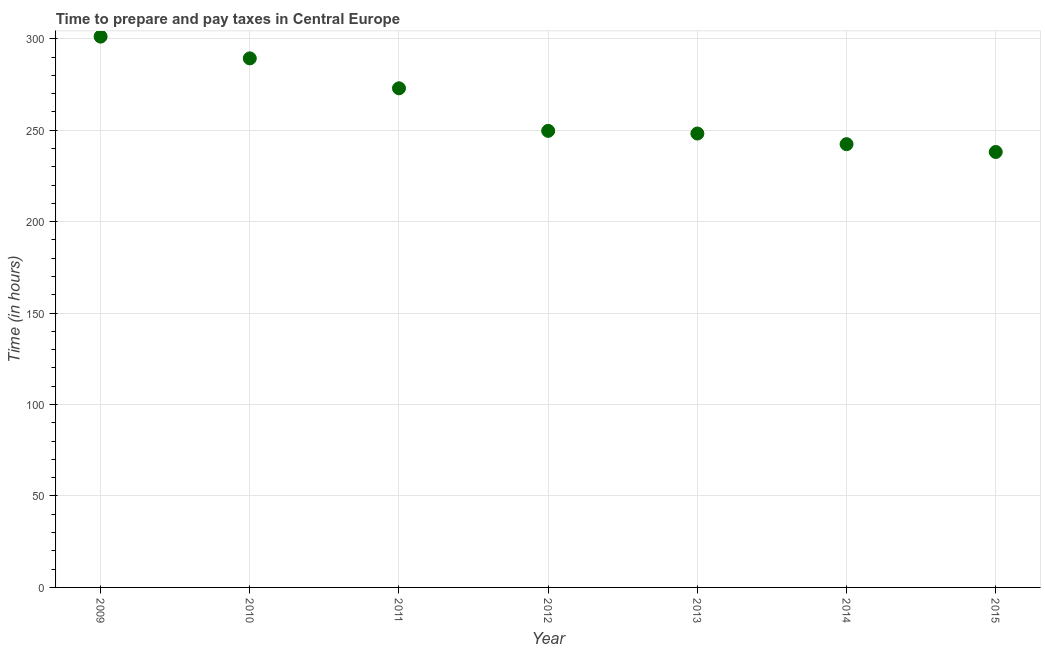What is the time to prepare and pay taxes in 2010?
Give a very brief answer. 289.27. Across all years, what is the maximum time to prepare and pay taxes?
Offer a terse response. 301.18. Across all years, what is the minimum time to prepare and pay taxes?
Your response must be concise. 238.09. In which year was the time to prepare and pay taxes maximum?
Your response must be concise. 2009. In which year was the time to prepare and pay taxes minimum?
Your response must be concise. 2015. What is the sum of the time to prepare and pay taxes?
Your response must be concise. 1841.64. What is the difference between the time to prepare and pay taxes in 2010 and 2013?
Offer a terse response. 41.09. What is the average time to prepare and pay taxes per year?
Make the answer very short. 263.09. What is the median time to prepare and pay taxes?
Provide a succinct answer. 249.64. Do a majority of the years between 2013 and 2009 (inclusive) have time to prepare and pay taxes greater than 240 hours?
Make the answer very short. Yes. What is the ratio of the time to prepare and pay taxes in 2011 to that in 2015?
Give a very brief answer. 1.15. What is the difference between the highest and the second highest time to prepare and pay taxes?
Make the answer very short. 11.91. What is the difference between the highest and the lowest time to prepare and pay taxes?
Your answer should be compact. 63.09. In how many years, is the time to prepare and pay taxes greater than the average time to prepare and pay taxes taken over all years?
Provide a short and direct response. 3. What is the difference between two consecutive major ticks on the Y-axis?
Your response must be concise. 50. Are the values on the major ticks of Y-axis written in scientific E-notation?
Your response must be concise. No. Does the graph contain grids?
Make the answer very short. Yes. What is the title of the graph?
Your answer should be compact. Time to prepare and pay taxes in Central Europe. What is the label or title of the X-axis?
Ensure brevity in your answer.  Year. What is the label or title of the Y-axis?
Keep it short and to the point. Time (in hours). What is the Time (in hours) in 2009?
Provide a short and direct response. 301.18. What is the Time (in hours) in 2010?
Provide a succinct answer. 289.27. What is the Time (in hours) in 2011?
Provide a succinct answer. 272.91. What is the Time (in hours) in 2012?
Provide a short and direct response. 249.64. What is the Time (in hours) in 2013?
Keep it short and to the point. 248.18. What is the Time (in hours) in 2014?
Give a very brief answer. 242.36. What is the Time (in hours) in 2015?
Provide a succinct answer. 238.09. What is the difference between the Time (in hours) in 2009 and 2010?
Offer a very short reply. 11.91. What is the difference between the Time (in hours) in 2009 and 2011?
Your answer should be compact. 28.27. What is the difference between the Time (in hours) in 2009 and 2012?
Ensure brevity in your answer.  51.55. What is the difference between the Time (in hours) in 2009 and 2013?
Provide a succinct answer. 53. What is the difference between the Time (in hours) in 2009 and 2014?
Your response must be concise. 58.82. What is the difference between the Time (in hours) in 2009 and 2015?
Provide a short and direct response. 63.09. What is the difference between the Time (in hours) in 2010 and 2011?
Make the answer very short. 16.36. What is the difference between the Time (in hours) in 2010 and 2012?
Your answer should be compact. 39.64. What is the difference between the Time (in hours) in 2010 and 2013?
Offer a very short reply. 41.09. What is the difference between the Time (in hours) in 2010 and 2014?
Keep it short and to the point. 46.91. What is the difference between the Time (in hours) in 2010 and 2015?
Offer a terse response. 51.18. What is the difference between the Time (in hours) in 2011 and 2012?
Provide a succinct answer. 23.27. What is the difference between the Time (in hours) in 2011 and 2013?
Provide a short and direct response. 24.73. What is the difference between the Time (in hours) in 2011 and 2014?
Offer a very short reply. 30.55. What is the difference between the Time (in hours) in 2011 and 2015?
Provide a short and direct response. 34.82. What is the difference between the Time (in hours) in 2012 and 2013?
Offer a very short reply. 1.45. What is the difference between the Time (in hours) in 2012 and 2014?
Provide a short and direct response. 7.27. What is the difference between the Time (in hours) in 2012 and 2015?
Provide a succinct answer. 11.55. What is the difference between the Time (in hours) in 2013 and 2014?
Provide a succinct answer. 5.82. What is the difference between the Time (in hours) in 2013 and 2015?
Your answer should be very brief. 10.09. What is the difference between the Time (in hours) in 2014 and 2015?
Ensure brevity in your answer.  4.27. What is the ratio of the Time (in hours) in 2009 to that in 2010?
Offer a terse response. 1.04. What is the ratio of the Time (in hours) in 2009 to that in 2011?
Give a very brief answer. 1.1. What is the ratio of the Time (in hours) in 2009 to that in 2012?
Provide a short and direct response. 1.21. What is the ratio of the Time (in hours) in 2009 to that in 2013?
Give a very brief answer. 1.21. What is the ratio of the Time (in hours) in 2009 to that in 2014?
Your answer should be very brief. 1.24. What is the ratio of the Time (in hours) in 2009 to that in 2015?
Provide a short and direct response. 1.26. What is the ratio of the Time (in hours) in 2010 to that in 2011?
Keep it short and to the point. 1.06. What is the ratio of the Time (in hours) in 2010 to that in 2012?
Ensure brevity in your answer.  1.16. What is the ratio of the Time (in hours) in 2010 to that in 2013?
Offer a terse response. 1.17. What is the ratio of the Time (in hours) in 2010 to that in 2014?
Provide a short and direct response. 1.19. What is the ratio of the Time (in hours) in 2010 to that in 2015?
Ensure brevity in your answer.  1.22. What is the ratio of the Time (in hours) in 2011 to that in 2012?
Keep it short and to the point. 1.09. What is the ratio of the Time (in hours) in 2011 to that in 2014?
Offer a very short reply. 1.13. What is the ratio of the Time (in hours) in 2011 to that in 2015?
Make the answer very short. 1.15. What is the ratio of the Time (in hours) in 2012 to that in 2014?
Provide a succinct answer. 1.03. What is the ratio of the Time (in hours) in 2012 to that in 2015?
Your answer should be compact. 1.05. What is the ratio of the Time (in hours) in 2013 to that in 2015?
Ensure brevity in your answer.  1.04. What is the ratio of the Time (in hours) in 2014 to that in 2015?
Ensure brevity in your answer.  1.02. 